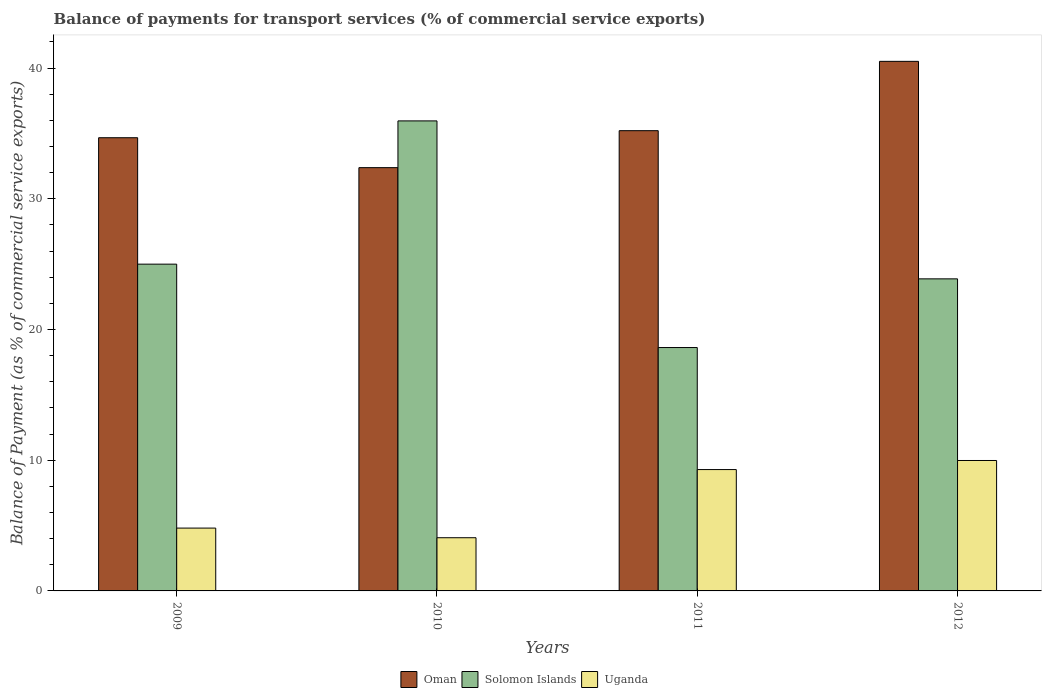How many groups of bars are there?
Give a very brief answer. 4. What is the label of the 4th group of bars from the left?
Provide a short and direct response. 2012. What is the balance of payments for transport services in Uganda in 2009?
Provide a short and direct response. 4.81. Across all years, what is the maximum balance of payments for transport services in Uganda?
Ensure brevity in your answer.  9.98. Across all years, what is the minimum balance of payments for transport services in Uganda?
Your answer should be compact. 4.07. What is the total balance of payments for transport services in Oman in the graph?
Your response must be concise. 142.78. What is the difference between the balance of payments for transport services in Oman in 2011 and that in 2012?
Give a very brief answer. -5.3. What is the difference between the balance of payments for transport services in Uganda in 2011 and the balance of payments for transport services in Oman in 2010?
Make the answer very short. -23.1. What is the average balance of payments for transport services in Oman per year?
Your response must be concise. 35.69. In the year 2012, what is the difference between the balance of payments for transport services in Solomon Islands and balance of payments for transport services in Uganda?
Offer a terse response. 13.9. What is the ratio of the balance of payments for transport services in Uganda in 2009 to that in 2011?
Ensure brevity in your answer.  0.52. Is the balance of payments for transport services in Uganda in 2009 less than that in 2012?
Give a very brief answer. Yes. What is the difference between the highest and the second highest balance of payments for transport services in Oman?
Ensure brevity in your answer.  5.3. What is the difference between the highest and the lowest balance of payments for transport services in Oman?
Your answer should be compact. 8.13. In how many years, is the balance of payments for transport services in Uganda greater than the average balance of payments for transport services in Uganda taken over all years?
Your answer should be very brief. 2. Is the sum of the balance of payments for transport services in Solomon Islands in 2010 and 2012 greater than the maximum balance of payments for transport services in Uganda across all years?
Provide a succinct answer. Yes. What does the 3rd bar from the left in 2009 represents?
Your answer should be compact. Uganda. What does the 2nd bar from the right in 2010 represents?
Keep it short and to the point. Solomon Islands. Is it the case that in every year, the sum of the balance of payments for transport services in Oman and balance of payments for transport services in Solomon Islands is greater than the balance of payments for transport services in Uganda?
Give a very brief answer. Yes. How many bars are there?
Make the answer very short. 12. Where does the legend appear in the graph?
Keep it short and to the point. Bottom center. How many legend labels are there?
Offer a terse response. 3. How are the legend labels stacked?
Provide a short and direct response. Horizontal. What is the title of the graph?
Your response must be concise. Balance of payments for transport services (% of commercial service exports). Does "Spain" appear as one of the legend labels in the graph?
Make the answer very short. No. What is the label or title of the Y-axis?
Your answer should be compact. Balance of Payment (as % of commercial service exports). What is the Balance of Payment (as % of commercial service exports) in Oman in 2009?
Provide a short and direct response. 34.67. What is the Balance of Payment (as % of commercial service exports) in Solomon Islands in 2009?
Make the answer very short. 25. What is the Balance of Payment (as % of commercial service exports) in Uganda in 2009?
Provide a short and direct response. 4.81. What is the Balance of Payment (as % of commercial service exports) of Oman in 2010?
Your answer should be compact. 32.38. What is the Balance of Payment (as % of commercial service exports) in Solomon Islands in 2010?
Your response must be concise. 35.96. What is the Balance of Payment (as % of commercial service exports) in Uganda in 2010?
Make the answer very short. 4.07. What is the Balance of Payment (as % of commercial service exports) of Oman in 2011?
Provide a short and direct response. 35.21. What is the Balance of Payment (as % of commercial service exports) in Solomon Islands in 2011?
Ensure brevity in your answer.  18.62. What is the Balance of Payment (as % of commercial service exports) in Uganda in 2011?
Offer a terse response. 9.28. What is the Balance of Payment (as % of commercial service exports) of Oman in 2012?
Keep it short and to the point. 40.51. What is the Balance of Payment (as % of commercial service exports) of Solomon Islands in 2012?
Provide a succinct answer. 23.87. What is the Balance of Payment (as % of commercial service exports) in Uganda in 2012?
Your answer should be very brief. 9.98. Across all years, what is the maximum Balance of Payment (as % of commercial service exports) in Oman?
Your response must be concise. 40.51. Across all years, what is the maximum Balance of Payment (as % of commercial service exports) in Solomon Islands?
Ensure brevity in your answer.  35.96. Across all years, what is the maximum Balance of Payment (as % of commercial service exports) of Uganda?
Provide a short and direct response. 9.98. Across all years, what is the minimum Balance of Payment (as % of commercial service exports) in Oman?
Your answer should be very brief. 32.38. Across all years, what is the minimum Balance of Payment (as % of commercial service exports) of Solomon Islands?
Offer a terse response. 18.62. Across all years, what is the minimum Balance of Payment (as % of commercial service exports) in Uganda?
Offer a very short reply. 4.07. What is the total Balance of Payment (as % of commercial service exports) of Oman in the graph?
Offer a terse response. 142.78. What is the total Balance of Payment (as % of commercial service exports) in Solomon Islands in the graph?
Your answer should be compact. 103.45. What is the total Balance of Payment (as % of commercial service exports) of Uganda in the graph?
Provide a short and direct response. 28.14. What is the difference between the Balance of Payment (as % of commercial service exports) of Oman in 2009 and that in 2010?
Ensure brevity in your answer.  2.29. What is the difference between the Balance of Payment (as % of commercial service exports) of Solomon Islands in 2009 and that in 2010?
Make the answer very short. -10.96. What is the difference between the Balance of Payment (as % of commercial service exports) in Uganda in 2009 and that in 2010?
Make the answer very short. 0.74. What is the difference between the Balance of Payment (as % of commercial service exports) in Oman in 2009 and that in 2011?
Keep it short and to the point. -0.54. What is the difference between the Balance of Payment (as % of commercial service exports) in Solomon Islands in 2009 and that in 2011?
Provide a short and direct response. 6.38. What is the difference between the Balance of Payment (as % of commercial service exports) of Uganda in 2009 and that in 2011?
Provide a short and direct response. -4.48. What is the difference between the Balance of Payment (as % of commercial service exports) of Oman in 2009 and that in 2012?
Offer a very short reply. -5.84. What is the difference between the Balance of Payment (as % of commercial service exports) of Solomon Islands in 2009 and that in 2012?
Provide a short and direct response. 1.12. What is the difference between the Balance of Payment (as % of commercial service exports) in Uganda in 2009 and that in 2012?
Make the answer very short. -5.17. What is the difference between the Balance of Payment (as % of commercial service exports) in Oman in 2010 and that in 2011?
Ensure brevity in your answer.  -2.83. What is the difference between the Balance of Payment (as % of commercial service exports) of Solomon Islands in 2010 and that in 2011?
Your answer should be very brief. 17.34. What is the difference between the Balance of Payment (as % of commercial service exports) of Uganda in 2010 and that in 2011?
Make the answer very short. -5.21. What is the difference between the Balance of Payment (as % of commercial service exports) in Oman in 2010 and that in 2012?
Give a very brief answer. -8.13. What is the difference between the Balance of Payment (as % of commercial service exports) in Solomon Islands in 2010 and that in 2012?
Provide a succinct answer. 12.08. What is the difference between the Balance of Payment (as % of commercial service exports) in Uganda in 2010 and that in 2012?
Your response must be concise. -5.91. What is the difference between the Balance of Payment (as % of commercial service exports) of Oman in 2011 and that in 2012?
Your answer should be very brief. -5.3. What is the difference between the Balance of Payment (as % of commercial service exports) of Solomon Islands in 2011 and that in 2012?
Provide a succinct answer. -5.25. What is the difference between the Balance of Payment (as % of commercial service exports) in Uganda in 2011 and that in 2012?
Offer a terse response. -0.69. What is the difference between the Balance of Payment (as % of commercial service exports) of Oman in 2009 and the Balance of Payment (as % of commercial service exports) of Solomon Islands in 2010?
Your answer should be very brief. -1.29. What is the difference between the Balance of Payment (as % of commercial service exports) in Oman in 2009 and the Balance of Payment (as % of commercial service exports) in Uganda in 2010?
Provide a succinct answer. 30.6. What is the difference between the Balance of Payment (as % of commercial service exports) in Solomon Islands in 2009 and the Balance of Payment (as % of commercial service exports) in Uganda in 2010?
Give a very brief answer. 20.93. What is the difference between the Balance of Payment (as % of commercial service exports) in Oman in 2009 and the Balance of Payment (as % of commercial service exports) in Solomon Islands in 2011?
Keep it short and to the point. 16.05. What is the difference between the Balance of Payment (as % of commercial service exports) of Oman in 2009 and the Balance of Payment (as % of commercial service exports) of Uganda in 2011?
Make the answer very short. 25.39. What is the difference between the Balance of Payment (as % of commercial service exports) in Solomon Islands in 2009 and the Balance of Payment (as % of commercial service exports) in Uganda in 2011?
Offer a terse response. 15.72. What is the difference between the Balance of Payment (as % of commercial service exports) of Oman in 2009 and the Balance of Payment (as % of commercial service exports) of Solomon Islands in 2012?
Your answer should be compact. 10.8. What is the difference between the Balance of Payment (as % of commercial service exports) in Oman in 2009 and the Balance of Payment (as % of commercial service exports) in Uganda in 2012?
Your answer should be very brief. 24.69. What is the difference between the Balance of Payment (as % of commercial service exports) in Solomon Islands in 2009 and the Balance of Payment (as % of commercial service exports) in Uganda in 2012?
Provide a succinct answer. 15.02. What is the difference between the Balance of Payment (as % of commercial service exports) in Oman in 2010 and the Balance of Payment (as % of commercial service exports) in Solomon Islands in 2011?
Your response must be concise. 13.76. What is the difference between the Balance of Payment (as % of commercial service exports) of Oman in 2010 and the Balance of Payment (as % of commercial service exports) of Uganda in 2011?
Offer a terse response. 23.1. What is the difference between the Balance of Payment (as % of commercial service exports) in Solomon Islands in 2010 and the Balance of Payment (as % of commercial service exports) in Uganda in 2011?
Your response must be concise. 26.67. What is the difference between the Balance of Payment (as % of commercial service exports) in Oman in 2010 and the Balance of Payment (as % of commercial service exports) in Solomon Islands in 2012?
Your answer should be compact. 8.51. What is the difference between the Balance of Payment (as % of commercial service exports) in Oman in 2010 and the Balance of Payment (as % of commercial service exports) in Uganda in 2012?
Offer a very short reply. 22.4. What is the difference between the Balance of Payment (as % of commercial service exports) in Solomon Islands in 2010 and the Balance of Payment (as % of commercial service exports) in Uganda in 2012?
Ensure brevity in your answer.  25.98. What is the difference between the Balance of Payment (as % of commercial service exports) in Oman in 2011 and the Balance of Payment (as % of commercial service exports) in Solomon Islands in 2012?
Your answer should be very brief. 11.34. What is the difference between the Balance of Payment (as % of commercial service exports) in Oman in 2011 and the Balance of Payment (as % of commercial service exports) in Uganda in 2012?
Offer a very short reply. 25.23. What is the difference between the Balance of Payment (as % of commercial service exports) in Solomon Islands in 2011 and the Balance of Payment (as % of commercial service exports) in Uganda in 2012?
Offer a very short reply. 8.64. What is the average Balance of Payment (as % of commercial service exports) in Oman per year?
Keep it short and to the point. 35.69. What is the average Balance of Payment (as % of commercial service exports) in Solomon Islands per year?
Your answer should be very brief. 25.86. What is the average Balance of Payment (as % of commercial service exports) in Uganda per year?
Your response must be concise. 7.03. In the year 2009, what is the difference between the Balance of Payment (as % of commercial service exports) in Oman and Balance of Payment (as % of commercial service exports) in Solomon Islands?
Offer a terse response. 9.67. In the year 2009, what is the difference between the Balance of Payment (as % of commercial service exports) of Oman and Balance of Payment (as % of commercial service exports) of Uganda?
Make the answer very short. 29.86. In the year 2009, what is the difference between the Balance of Payment (as % of commercial service exports) in Solomon Islands and Balance of Payment (as % of commercial service exports) in Uganda?
Provide a short and direct response. 20.19. In the year 2010, what is the difference between the Balance of Payment (as % of commercial service exports) in Oman and Balance of Payment (as % of commercial service exports) in Solomon Islands?
Ensure brevity in your answer.  -3.58. In the year 2010, what is the difference between the Balance of Payment (as % of commercial service exports) of Oman and Balance of Payment (as % of commercial service exports) of Uganda?
Provide a succinct answer. 28.31. In the year 2010, what is the difference between the Balance of Payment (as % of commercial service exports) of Solomon Islands and Balance of Payment (as % of commercial service exports) of Uganda?
Make the answer very short. 31.89. In the year 2011, what is the difference between the Balance of Payment (as % of commercial service exports) of Oman and Balance of Payment (as % of commercial service exports) of Solomon Islands?
Keep it short and to the point. 16.59. In the year 2011, what is the difference between the Balance of Payment (as % of commercial service exports) of Oman and Balance of Payment (as % of commercial service exports) of Uganda?
Offer a terse response. 25.93. In the year 2011, what is the difference between the Balance of Payment (as % of commercial service exports) in Solomon Islands and Balance of Payment (as % of commercial service exports) in Uganda?
Your answer should be very brief. 9.34. In the year 2012, what is the difference between the Balance of Payment (as % of commercial service exports) of Oman and Balance of Payment (as % of commercial service exports) of Solomon Islands?
Your answer should be very brief. 16.64. In the year 2012, what is the difference between the Balance of Payment (as % of commercial service exports) of Oman and Balance of Payment (as % of commercial service exports) of Uganda?
Offer a very short reply. 30.54. In the year 2012, what is the difference between the Balance of Payment (as % of commercial service exports) in Solomon Islands and Balance of Payment (as % of commercial service exports) in Uganda?
Your answer should be very brief. 13.9. What is the ratio of the Balance of Payment (as % of commercial service exports) of Oman in 2009 to that in 2010?
Offer a terse response. 1.07. What is the ratio of the Balance of Payment (as % of commercial service exports) in Solomon Islands in 2009 to that in 2010?
Offer a very short reply. 0.7. What is the ratio of the Balance of Payment (as % of commercial service exports) in Uganda in 2009 to that in 2010?
Provide a succinct answer. 1.18. What is the ratio of the Balance of Payment (as % of commercial service exports) of Oman in 2009 to that in 2011?
Your answer should be very brief. 0.98. What is the ratio of the Balance of Payment (as % of commercial service exports) in Solomon Islands in 2009 to that in 2011?
Provide a succinct answer. 1.34. What is the ratio of the Balance of Payment (as % of commercial service exports) of Uganda in 2009 to that in 2011?
Ensure brevity in your answer.  0.52. What is the ratio of the Balance of Payment (as % of commercial service exports) of Oman in 2009 to that in 2012?
Your answer should be very brief. 0.86. What is the ratio of the Balance of Payment (as % of commercial service exports) of Solomon Islands in 2009 to that in 2012?
Offer a terse response. 1.05. What is the ratio of the Balance of Payment (as % of commercial service exports) in Uganda in 2009 to that in 2012?
Your answer should be compact. 0.48. What is the ratio of the Balance of Payment (as % of commercial service exports) in Oman in 2010 to that in 2011?
Give a very brief answer. 0.92. What is the ratio of the Balance of Payment (as % of commercial service exports) of Solomon Islands in 2010 to that in 2011?
Offer a terse response. 1.93. What is the ratio of the Balance of Payment (as % of commercial service exports) in Uganda in 2010 to that in 2011?
Provide a succinct answer. 0.44. What is the ratio of the Balance of Payment (as % of commercial service exports) in Oman in 2010 to that in 2012?
Provide a succinct answer. 0.8. What is the ratio of the Balance of Payment (as % of commercial service exports) in Solomon Islands in 2010 to that in 2012?
Keep it short and to the point. 1.51. What is the ratio of the Balance of Payment (as % of commercial service exports) of Uganda in 2010 to that in 2012?
Your answer should be compact. 0.41. What is the ratio of the Balance of Payment (as % of commercial service exports) in Oman in 2011 to that in 2012?
Your response must be concise. 0.87. What is the ratio of the Balance of Payment (as % of commercial service exports) in Solomon Islands in 2011 to that in 2012?
Provide a succinct answer. 0.78. What is the ratio of the Balance of Payment (as % of commercial service exports) in Uganda in 2011 to that in 2012?
Your answer should be compact. 0.93. What is the difference between the highest and the second highest Balance of Payment (as % of commercial service exports) in Oman?
Your answer should be very brief. 5.3. What is the difference between the highest and the second highest Balance of Payment (as % of commercial service exports) of Solomon Islands?
Your response must be concise. 10.96. What is the difference between the highest and the second highest Balance of Payment (as % of commercial service exports) of Uganda?
Provide a succinct answer. 0.69. What is the difference between the highest and the lowest Balance of Payment (as % of commercial service exports) in Oman?
Your response must be concise. 8.13. What is the difference between the highest and the lowest Balance of Payment (as % of commercial service exports) of Solomon Islands?
Offer a terse response. 17.34. What is the difference between the highest and the lowest Balance of Payment (as % of commercial service exports) of Uganda?
Make the answer very short. 5.91. 